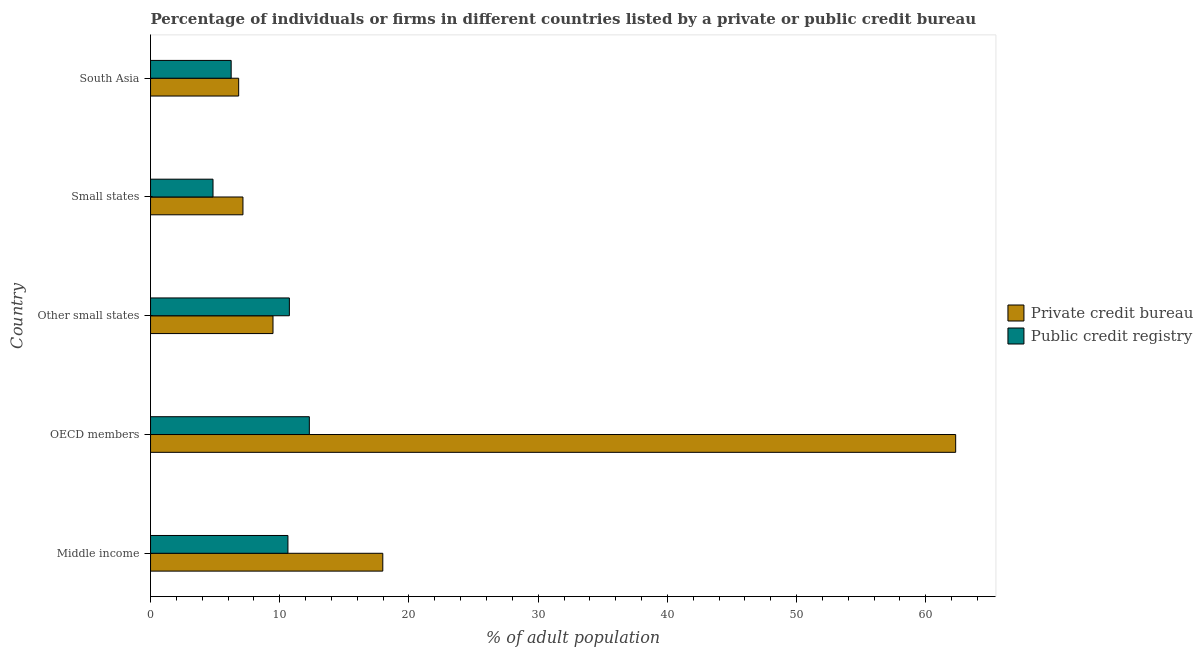How many different coloured bars are there?
Ensure brevity in your answer.  2. How many groups of bars are there?
Provide a succinct answer. 5. Are the number of bars per tick equal to the number of legend labels?
Ensure brevity in your answer.  Yes. Are the number of bars on each tick of the Y-axis equal?
Offer a very short reply. Yes. How many bars are there on the 4th tick from the bottom?
Make the answer very short. 2. What is the label of the 1st group of bars from the top?
Your response must be concise. South Asia. What is the percentage of firms listed by public credit bureau in Other small states?
Offer a terse response. 10.74. Across all countries, what is the maximum percentage of firms listed by public credit bureau?
Ensure brevity in your answer.  12.29. Across all countries, what is the minimum percentage of firms listed by private credit bureau?
Ensure brevity in your answer.  6.82. In which country was the percentage of firms listed by public credit bureau minimum?
Make the answer very short. Small states. What is the total percentage of firms listed by public credit bureau in the graph?
Your answer should be very brief. 44.74. What is the difference between the percentage of firms listed by public credit bureau in OECD members and that in Small states?
Keep it short and to the point. 7.46. What is the difference between the percentage of firms listed by private credit bureau in Middle income and the percentage of firms listed by public credit bureau in Small states?
Provide a short and direct response. 13.14. What is the average percentage of firms listed by public credit bureau per country?
Keep it short and to the point. 8.95. What is the difference between the percentage of firms listed by public credit bureau and percentage of firms listed by private credit bureau in Small states?
Your answer should be very brief. -2.32. What is the ratio of the percentage of firms listed by public credit bureau in Other small states to that in Small states?
Make the answer very short. 2.22. What is the difference between the highest and the second highest percentage of firms listed by public credit bureau?
Give a very brief answer. 1.55. What is the difference between the highest and the lowest percentage of firms listed by public credit bureau?
Give a very brief answer. 7.46. Is the sum of the percentage of firms listed by private credit bureau in Middle income and South Asia greater than the maximum percentage of firms listed by public credit bureau across all countries?
Offer a terse response. Yes. What does the 2nd bar from the top in Other small states represents?
Offer a very short reply. Private credit bureau. What does the 1st bar from the bottom in South Asia represents?
Keep it short and to the point. Private credit bureau. How many countries are there in the graph?
Provide a succinct answer. 5. What is the title of the graph?
Offer a very short reply. Percentage of individuals or firms in different countries listed by a private or public credit bureau. What is the label or title of the X-axis?
Give a very brief answer. % of adult population. What is the label or title of the Y-axis?
Provide a succinct answer. Country. What is the % of adult population of Private credit bureau in Middle income?
Keep it short and to the point. 17.97. What is the % of adult population in Public credit registry in Middle income?
Make the answer very short. 10.63. What is the % of adult population of Private credit bureau in OECD members?
Ensure brevity in your answer.  62.31. What is the % of adult population in Public credit registry in OECD members?
Your answer should be very brief. 12.29. What is the % of adult population in Private credit bureau in Other small states?
Offer a terse response. 9.48. What is the % of adult population of Public credit registry in Other small states?
Give a very brief answer. 10.74. What is the % of adult population of Private credit bureau in Small states?
Make the answer very short. 7.15. What is the % of adult population of Public credit registry in Small states?
Your answer should be compact. 4.83. What is the % of adult population in Private credit bureau in South Asia?
Provide a short and direct response. 6.82. What is the % of adult population in Public credit registry in South Asia?
Give a very brief answer. 6.24. Across all countries, what is the maximum % of adult population in Private credit bureau?
Give a very brief answer. 62.31. Across all countries, what is the maximum % of adult population in Public credit registry?
Offer a terse response. 12.29. Across all countries, what is the minimum % of adult population of Private credit bureau?
Offer a terse response. 6.82. Across all countries, what is the minimum % of adult population in Public credit registry?
Provide a short and direct response. 4.83. What is the total % of adult population of Private credit bureau in the graph?
Your response must be concise. 103.73. What is the total % of adult population in Public credit registry in the graph?
Your answer should be very brief. 44.74. What is the difference between the % of adult population of Private credit bureau in Middle income and that in OECD members?
Make the answer very short. -44.34. What is the difference between the % of adult population of Public credit registry in Middle income and that in OECD members?
Make the answer very short. -1.66. What is the difference between the % of adult population in Private credit bureau in Middle income and that in Other small states?
Give a very brief answer. 8.5. What is the difference between the % of adult population in Public credit registry in Middle income and that in Other small states?
Offer a terse response. -0.11. What is the difference between the % of adult population of Private credit bureau in Middle income and that in Small states?
Provide a short and direct response. 10.82. What is the difference between the % of adult population of Public credit registry in Middle income and that in Small states?
Ensure brevity in your answer.  5.8. What is the difference between the % of adult population of Private credit bureau in Middle income and that in South Asia?
Ensure brevity in your answer.  11.15. What is the difference between the % of adult population of Public credit registry in Middle income and that in South Asia?
Your response must be concise. 4.39. What is the difference between the % of adult population in Private credit bureau in OECD members and that in Other small states?
Offer a terse response. 52.83. What is the difference between the % of adult population of Public credit registry in OECD members and that in Other small states?
Keep it short and to the point. 1.55. What is the difference between the % of adult population in Private credit bureau in OECD members and that in Small states?
Provide a succinct answer. 55.16. What is the difference between the % of adult population in Public credit registry in OECD members and that in Small states?
Offer a very short reply. 7.46. What is the difference between the % of adult population of Private credit bureau in OECD members and that in South Asia?
Offer a terse response. 55.49. What is the difference between the % of adult population of Public credit registry in OECD members and that in South Asia?
Keep it short and to the point. 6.05. What is the difference between the % of adult population of Private credit bureau in Other small states and that in Small states?
Provide a succinct answer. 2.33. What is the difference between the % of adult population in Public credit registry in Other small states and that in Small states?
Your response must be concise. 5.91. What is the difference between the % of adult population in Private credit bureau in Other small states and that in South Asia?
Offer a terse response. 2.66. What is the difference between the % of adult population of Public credit registry in Other small states and that in South Asia?
Your response must be concise. 4.5. What is the difference between the % of adult population of Private credit bureau in Small states and that in South Asia?
Ensure brevity in your answer.  0.33. What is the difference between the % of adult population in Public credit registry in Small states and that in South Asia?
Offer a very short reply. -1.41. What is the difference between the % of adult population in Private credit bureau in Middle income and the % of adult population in Public credit registry in OECD members?
Offer a very short reply. 5.68. What is the difference between the % of adult population in Private credit bureau in Middle income and the % of adult population in Public credit registry in Other small states?
Your answer should be compact. 7.23. What is the difference between the % of adult population in Private credit bureau in Middle income and the % of adult population in Public credit registry in Small states?
Provide a succinct answer. 13.14. What is the difference between the % of adult population in Private credit bureau in Middle income and the % of adult population in Public credit registry in South Asia?
Keep it short and to the point. 11.73. What is the difference between the % of adult population of Private credit bureau in OECD members and the % of adult population of Public credit registry in Other small states?
Give a very brief answer. 51.57. What is the difference between the % of adult population in Private credit bureau in OECD members and the % of adult population in Public credit registry in Small states?
Ensure brevity in your answer.  57.47. What is the difference between the % of adult population in Private credit bureau in OECD members and the % of adult population in Public credit registry in South Asia?
Provide a short and direct response. 56.07. What is the difference between the % of adult population in Private credit bureau in Other small states and the % of adult population in Public credit registry in Small states?
Keep it short and to the point. 4.64. What is the difference between the % of adult population of Private credit bureau in Other small states and the % of adult population of Public credit registry in South Asia?
Your answer should be compact. 3.24. What is the difference between the % of adult population of Private credit bureau in Small states and the % of adult population of Public credit registry in South Asia?
Ensure brevity in your answer.  0.91. What is the average % of adult population in Private credit bureau per country?
Your answer should be compact. 20.75. What is the average % of adult population in Public credit registry per country?
Ensure brevity in your answer.  8.95. What is the difference between the % of adult population in Private credit bureau and % of adult population in Public credit registry in Middle income?
Offer a very short reply. 7.34. What is the difference between the % of adult population in Private credit bureau and % of adult population in Public credit registry in OECD members?
Offer a very short reply. 50.02. What is the difference between the % of adult population of Private credit bureau and % of adult population of Public credit registry in Other small states?
Provide a succinct answer. -1.27. What is the difference between the % of adult population of Private credit bureau and % of adult population of Public credit registry in Small states?
Your response must be concise. 2.32. What is the difference between the % of adult population in Private credit bureau and % of adult population in Public credit registry in South Asia?
Keep it short and to the point. 0.58. What is the ratio of the % of adult population of Private credit bureau in Middle income to that in OECD members?
Make the answer very short. 0.29. What is the ratio of the % of adult population of Public credit registry in Middle income to that in OECD members?
Your answer should be very brief. 0.87. What is the ratio of the % of adult population in Private credit bureau in Middle income to that in Other small states?
Ensure brevity in your answer.  1.9. What is the ratio of the % of adult population in Private credit bureau in Middle income to that in Small states?
Ensure brevity in your answer.  2.51. What is the ratio of the % of adult population in Public credit registry in Middle income to that in Small states?
Offer a terse response. 2.2. What is the ratio of the % of adult population in Private credit bureau in Middle income to that in South Asia?
Offer a terse response. 2.64. What is the ratio of the % of adult population of Public credit registry in Middle income to that in South Asia?
Offer a very short reply. 1.7. What is the ratio of the % of adult population of Private credit bureau in OECD members to that in Other small states?
Provide a short and direct response. 6.57. What is the ratio of the % of adult population of Public credit registry in OECD members to that in Other small states?
Offer a terse response. 1.14. What is the ratio of the % of adult population in Private credit bureau in OECD members to that in Small states?
Your response must be concise. 8.71. What is the ratio of the % of adult population of Public credit registry in OECD members to that in Small states?
Keep it short and to the point. 2.54. What is the ratio of the % of adult population of Private credit bureau in OECD members to that in South Asia?
Make the answer very short. 9.14. What is the ratio of the % of adult population in Public credit registry in OECD members to that in South Asia?
Your response must be concise. 1.97. What is the ratio of the % of adult population in Private credit bureau in Other small states to that in Small states?
Your response must be concise. 1.33. What is the ratio of the % of adult population of Public credit registry in Other small states to that in Small states?
Ensure brevity in your answer.  2.22. What is the ratio of the % of adult population in Private credit bureau in Other small states to that in South Asia?
Make the answer very short. 1.39. What is the ratio of the % of adult population in Public credit registry in Other small states to that in South Asia?
Your answer should be compact. 1.72. What is the ratio of the % of adult population of Private credit bureau in Small states to that in South Asia?
Offer a very short reply. 1.05. What is the ratio of the % of adult population of Public credit registry in Small states to that in South Asia?
Your response must be concise. 0.77. What is the difference between the highest and the second highest % of adult population in Private credit bureau?
Offer a terse response. 44.34. What is the difference between the highest and the second highest % of adult population of Public credit registry?
Make the answer very short. 1.55. What is the difference between the highest and the lowest % of adult population of Private credit bureau?
Ensure brevity in your answer.  55.49. What is the difference between the highest and the lowest % of adult population of Public credit registry?
Offer a terse response. 7.46. 